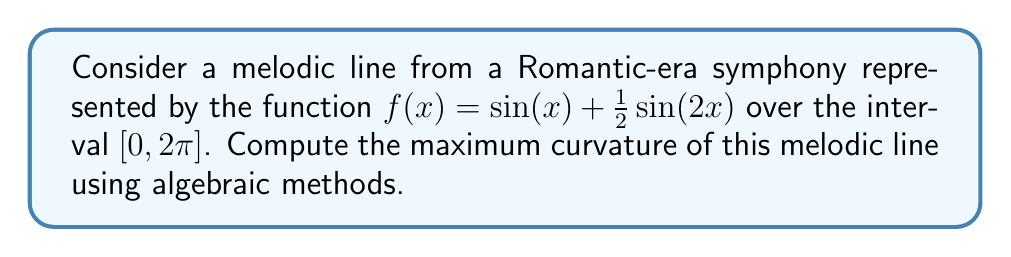Solve this math problem. To find the maximum curvature of the melodic line, we'll follow these steps:

1) The curvature of a function $f(x)$ is given by:

   $$\kappa(x) = \frac{|f''(x)|}{(1 + [f'(x)]^2)^{3/2}}$$

2) First, let's calculate $f'(x)$ and $f''(x)$:
   
   $f'(x) = \cos(x) + \cos(2x)$
   $f''(x) = -\sin(x) - 2\sin(2x)$

3) Now, we substitute these into the curvature formula:

   $$\kappa(x) = \frac{|\sin(x) + 2\sin(2x)|}{(1 + [\cos(x) + \cos(2x)]^2)^{3/2}}$$

4) To find the maximum curvature, we need to find where the derivative of $\kappa(x)$ equals zero. However, this is a complex expression. Instead, we can use the fact that the maximum curvature often occurs where $f''(x)$ is at its maximum magnitude.

5) The magnitude of $f''(x)$ is maximized when $\sin(x)$ and $\sin(2x)$ are both at their extrema and have the same sign. This occurs at $x = \frac{\pi}{6}$ and $x = \frac{7\pi}{6}$.

6) Let's evaluate the curvature at $x = \frac{\pi}{6}$:

   $f''(\frac{\pi}{6}) = -\sin(\frac{\pi}{6}) - 2\sin(\frac{\pi}{3}) = -\frac{1}{2} - \sqrt{3} = -2.232$

   $f'(\frac{\pi}{6}) = \cos(\frac{\pi}{6}) + \cos(\frac{\pi}{3}) = \frac{\sqrt{3}}{2} + \frac{1}{2} = 1.366$

   $$\kappa(\frac{\pi}{6}) = \frac{2.232}{(1 + 1.366^2)^{3/2}} = 0.6834$$

7) Due to the symmetry of the function, this will be the maximum curvature over the entire interval.
Answer: $0.6834$ 